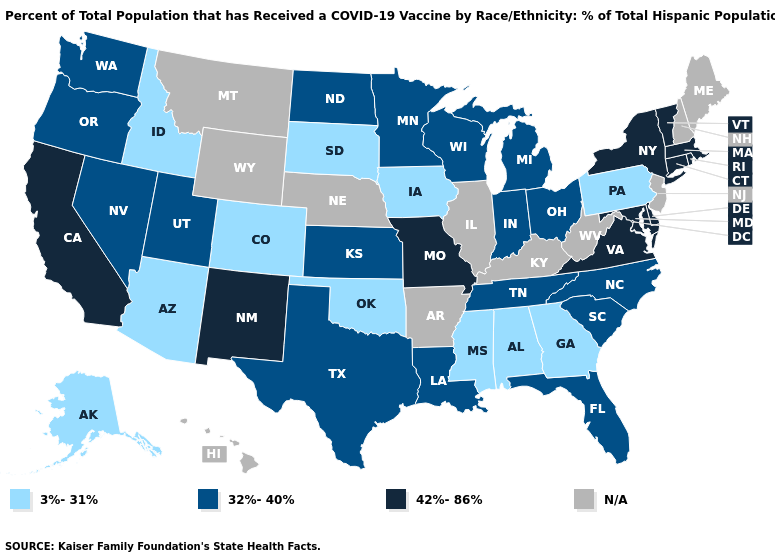Among the states that border Nevada , which have the highest value?
Be succinct. California. What is the lowest value in the Northeast?
Be succinct. 3%-31%. Does the map have missing data?
Quick response, please. Yes. What is the highest value in the MidWest ?
Be succinct. 42%-86%. Among the states that border Colorado , which have the lowest value?
Short answer required. Arizona, Oklahoma. Name the states that have a value in the range 3%-31%?
Give a very brief answer. Alabama, Alaska, Arizona, Colorado, Georgia, Idaho, Iowa, Mississippi, Oklahoma, Pennsylvania, South Dakota. What is the value of South Carolina?
Answer briefly. 32%-40%. What is the lowest value in the West?
Short answer required. 3%-31%. How many symbols are there in the legend?
Short answer required. 4. How many symbols are there in the legend?
Quick response, please. 4. Does the map have missing data?
Be succinct. Yes. Which states have the lowest value in the USA?
Answer briefly. Alabama, Alaska, Arizona, Colorado, Georgia, Idaho, Iowa, Mississippi, Oklahoma, Pennsylvania, South Dakota. What is the value of Alabama?
Concise answer only. 3%-31%. 